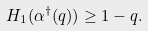Convert formula to latex. <formula><loc_0><loc_0><loc_500><loc_500>H _ { 1 } ( \alpha ^ { \dagger } ( q ) ) \geq 1 - q .</formula> 